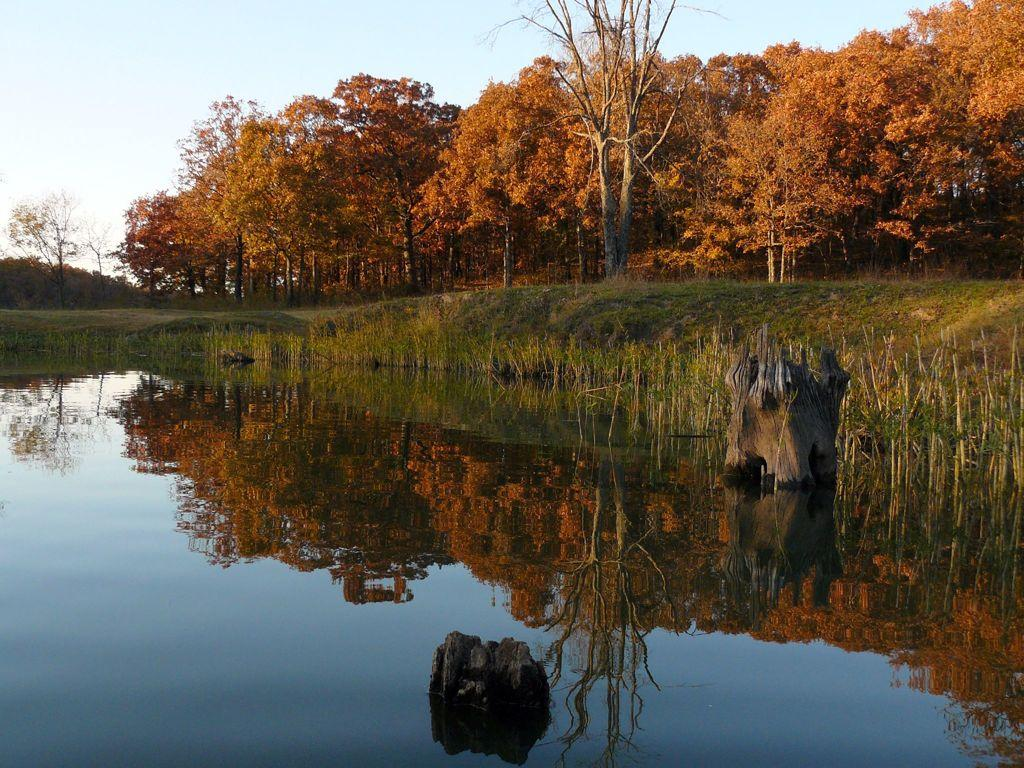What is one of the natural elements present in the image? There is water in the image. What type of vegetation can be seen in the image? There is grass and trees visible in the image. What is the color of the sky in the image? The sky is blue in the image. How many hydrants are visible in the image? There are no hydrants present in the image. What type of rail system can be seen in the image? There is no rail system present in the image. 